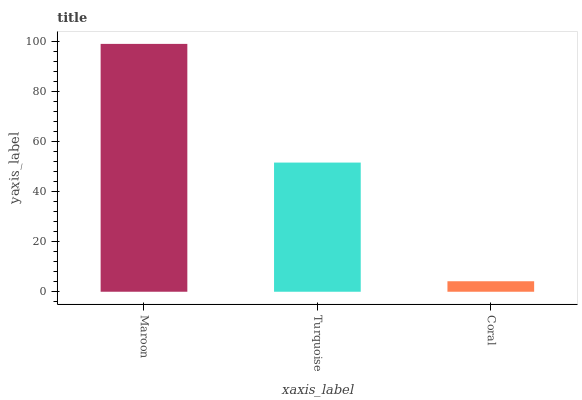Is Coral the minimum?
Answer yes or no. Yes. Is Maroon the maximum?
Answer yes or no. Yes. Is Turquoise the minimum?
Answer yes or no. No. Is Turquoise the maximum?
Answer yes or no. No. Is Maroon greater than Turquoise?
Answer yes or no. Yes. Is Turquoise less than Maroon?
Answer yes or no. Yes. Is Turquoise greater than Maroon?
Answer yes or no. No. Is Maroon less than Turquoise?
Answer yes or no. No. Is Turquoise the high median?
Answer yes or no. Yes. Is Turquoise the low median?
Answer yes or no. Yes. Is Maroon the high median?
Answer yes or no. No. Is Maroon the low median?
Answer yes or no. No. 